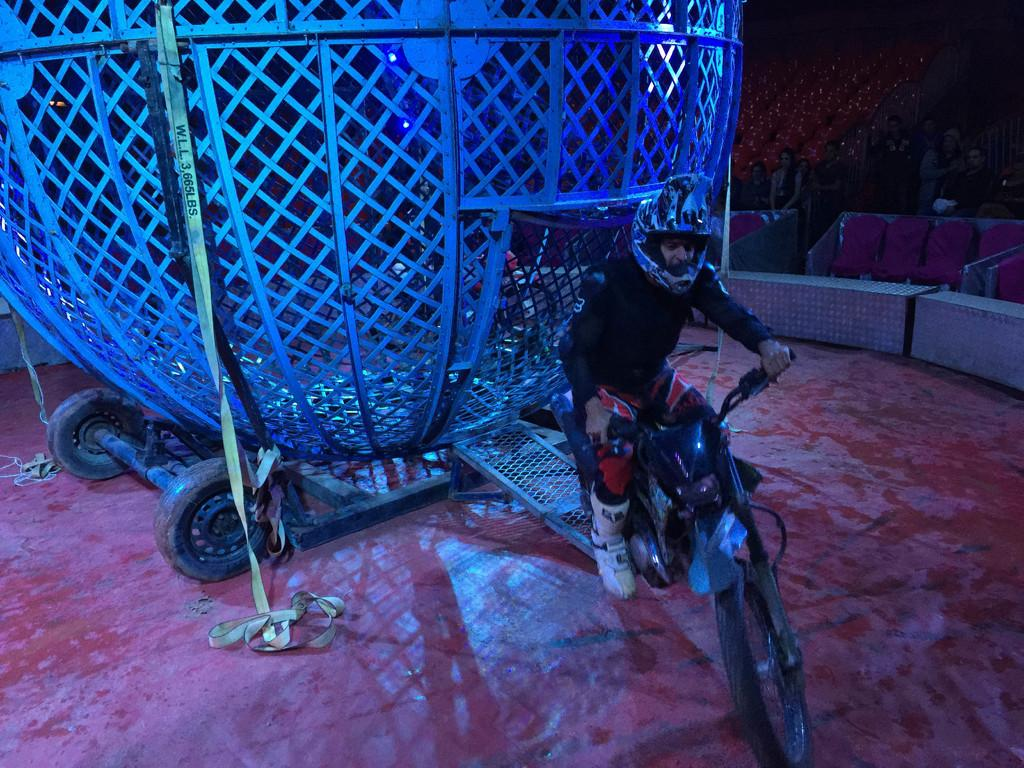Where was the image taken? The image was clicked outside. What can be seen in the image besides the person? There is a cycle in the image, and a person is sitting on it. What safety precaution is the person taking while riding the cycle? The person is wearing a helmet. Can you describe the unspecified object or element behind the person? Unfortunately, the facts provided do not give any details about the object or element behind the person. What type of payment is being made in the image? There is no indication of any payment being made in the image. How many jail cells can be seen in the image? There are no jail cells present in the image. 